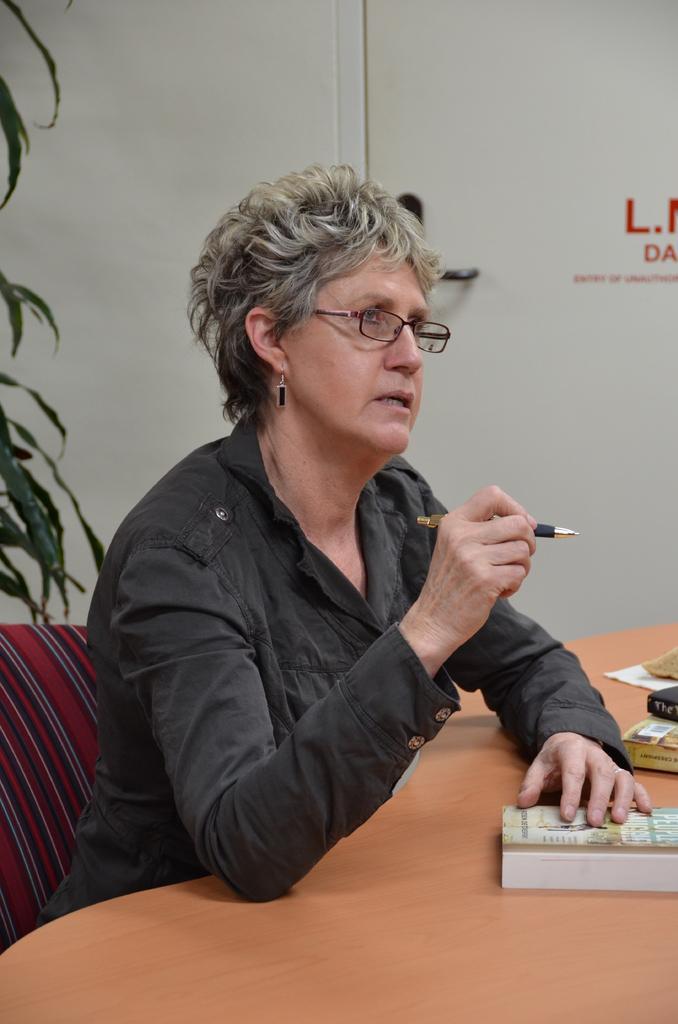Please provide a concise description of this image. There is a woman sitting in a chair in front of table and there are books on a table. 